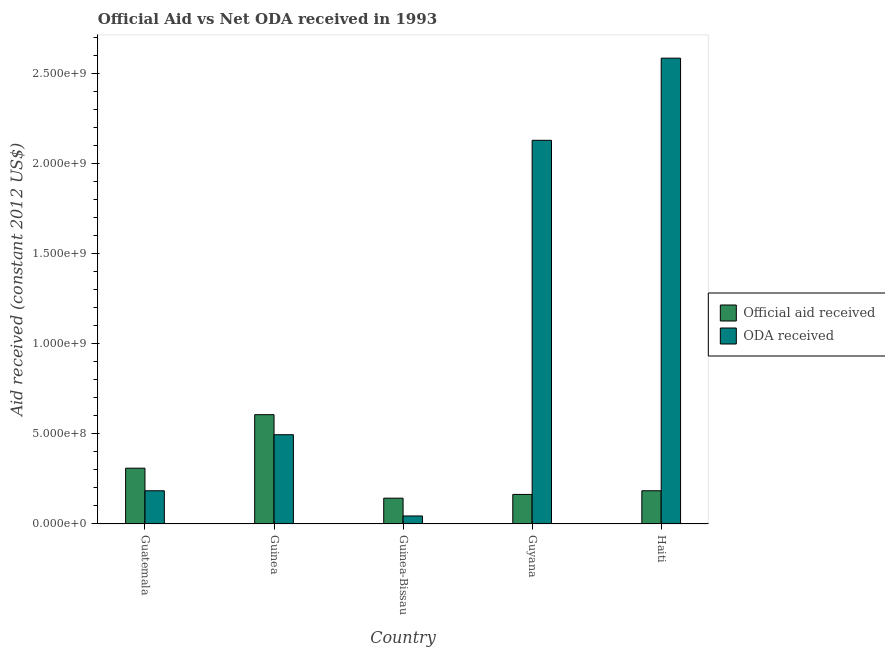How many different coloured bars are there?
Your answer should be very brief. 2. How many groups of bars are there?
Make the answer very short. 5. Are the number of bars per tick equal to the number of legend labels?
Make the answer very short. Yes. What is the label of the 1st group of bars from the left?
Offer a very short reply. Guatemala. In how many cases, is the number of bars for a given country not equal to the number of legend labels?
Give a very brief answer. 0. What is the official aid received in Haiti?
Make the answer very short. 1.84e+08. Across all countries, what is the maximum oda received?
Give a very brief answer. 2.59e+09. Across all countries, what is the minimum oda received?
Make the answer very short. 4.45e+07. In which country was the official aid received maximum?
Keep it short and to the point. Guinea. In which country was the oda received minimum?
Keep it short and to the point. Guinea-Bissau. What is the total official aid received in the graph?
Your response must be concise. 1.41e+09. What is the difference between the oda received in Guatemala and that in Guyana?
Offer a very short reply. -1.95e+09. What is the difference between the official aid received in Guyana and the oda received in Guinea?
Keep it short and to the point. -3.32e+08. What is the average official aid received per country?
Provide a short and direct response. 2.82e+08. What is the difference between the oda received and official aid received in Guatemala?
Provide a short and direct response. -1.25e+08. What is the ratio of the oda received in Guatemala to that in Guyana?
Make the answer very short. 0.09. Is the oda received in Guyana less than that in Haiti?
Provide a short and direct response. Yes. Is the difference between the oda received in Guinea and Haiti greater than the difference between the official aid received in Guinea and Haiti?
Your response must be concise. No. What is the difference between the highest and the second highest oda received?
Provide a short and direct response. 4.56e+08. What is the difference between the highest and the lowest official aid received?
Your answer should be compact. 4.64e+08. Is the sum of the official aid received in Guinea and Guinea-Bissau greater than the maximum oda received across all countries?
Ensure brevity in your answer.  No. What does the 1st bar from the left in Haiti represents?
Offer a terse response. Official aid received. What does the 1st bar from the right in Guinea-Bissau represents?
Provide a succinct answer. ODA received. How many bars are there?
Make the answer very short. 10. How many countries are there in the graph?
Your response must be concise. 5. What is the difference between two consecutive major ticks on the Y-axis?
Make the answer very short. 5.00e+08. Does the graph contain grids?
Ensure brevity in your answer.  No. Where does the legend appear in the graph?
Ensure brevity in your answer.  Center right. How many legend labels are there?
Make the answer very short. 2. How are the legend labels stacked?
Your answer should be very brief. Vertical. What is the title of the graph?
Offer a terse response. Official Aid vs Net ODA received in 1993 . Does "Secondary education" appear as one of the legend labels in the graph?
Offer a terse response. No. What is the label or title of the X-axis?
Your response must be concise. Country. What is the label or title of the Y-axis?
Your answer should be very brief. Aid received (constant 2012 US$). What is the Aid received (constant 2012 US$) in Official aid received in Guatemala?
Your answer should be compact. 3.10e+08. What is the Aid received (constant 2012 US$) of ODA received in Guatemala?
Ensure brevity in your answer.  1.84e+08. What is the Aid received (constant 2012 US$) of Official aid received in Guinea?
Keep it short and to the point. 6.07e+08. What is the Aid received (constant 2012 US$) in ODA received in Guinea?
Make the answer very short. 4.96e+08. What is the Aid received (constant 2012 US$) of Official aid received in Guinea-Bissau?
Your answer should be very brief. 1.43e+08. What is the Aid received (constant 2012 US$) of ODA received in Guinea-Bissau?
Make the answer very short. 4.45e+07. What is the Aid received (constant 2012 US$) in Official aid received in Guyana?
Make the answer very short. 1.64e+08. What is the Aid received (constant 2012 US$) in ODA received in Guyana?
Your answer should be compact. 2.13e+09. What is the Aid received (constant 2012 US$) of Official aid received in Haiti?
Your answer should be compact. 1.84e+08. What is the Aid received (constant 2012 US$) of ODA received in Haiti?
Ensure brevity in your answer.  2.59e+09. Across all countries, what is the maximum Aid received (constant 2012 US$) of Official aid received?
Offer a very short reply. 6.07e+08. Across all countries, what is the maximum Aid received (constant 2012 US$) of ODA received?
Provide a succinct answer. 2.59e+09. Across all countries, what is the minimum Aid received (constant 2012 US$) in Official aid received?
Provide a succinct answer. 1.43e+08. Across all countries, what is the minimum Aid received (constant 2012 US$) of ODA received?
Make the answer very short. 4.45e+07. What is the total Aid received (constant 2012 US$) in Official aid received in the graph?
Your answer should be very brief. 1.41e+09. What is the total Aid received (constant 2012 US$) in ODA received in the graph?
Keep it short and to the point. 5.44e+09. What is the difference between the Aid received (constant 2012 US$) of Official aid received in Guatemala and that in Guinea?
Make the answer very short. -2.97e+08. What is the difference between the Aid received (constant 2012 US$) in ODA received in Guatemala and that in Guinea?
Make the answer very short. -3.11e+08. What is the difference between the Aid received (constant 2012 US$) in Official aid received in Guatemala and that in Guinea-Bissau?
Give a very brief answer. 1.67e+08. What is the difference between the Aid received (constant 2012 US$) in ODA received in Guatemala and that in Guinea-Bissau?
Your response must be concise. 1.40e+08. What is the difference between the Aid received (constant 2012 US$) of Official aid received in Guatemala and that in Guyana?
Ensure brevity in your answer.  1.46e+08. What is the difference between the Aid received (constant 2012 US$) in ODA received in Guatemala and that in Guyana?
Your answer should be compact. -1.95e+09. What is the difference between the Aid received (constant 2012 US$) in Official aid received in Guatemala and that in Haiti?
Your response must be concise. 1.25e+08. What is the difference between the Aid received (constant 2012 US$) in ODA received in Guatemala and that in Haiti?
Your response must be concise. -2.40e+09. What is the difference between the Aid received (constant 2012 US$) in Official aid received in Guinea and that in Guinea-Bissau?
Offer a very short reply. 4.64e+08. What is the difference between the Aid received (constant 2012 US$) of ODA received in Guinea and that in Guinea-Bissau?
Your answer should be compact. 4.51e+08. What is the difference between the Aid received (constant 2012 US$) of Official aid received in Guinea and that in Guyana?
Ensure brevity in your answer.  4.43e+08. What is the difference between the Aid received (constant 2012 US$) of ODA received in Guinea and that in Guyana?
Ensure brevity in your answer.  -1.63e+09. What is the difference between the Aid received (constant 2012 US$) in Official aid received in Guinea and that in Haiti?
Make the answer very short. 4.22e+08. What is the difference between the Aid received (constant 2012 US$) of ODA received in Guinea and that in Haiti?
Ensure brevity in your answer.  -2.09e+09. What is the difference between the Aid received (constant 2012 US$) of Official aid received in Guinea-Bissau and that in Guyana?
Offer a very short reply. -2.08e+07. What is the difference between the Aid received (constant 2012 US$) of ODA received in Guinea-Bissau and that in Guyana?
Give a very brief answer. -2.09e+09. What is the difference between the Aid received (constant 2012 US$) in Official aid received in Guinea-Bissau and that in Haiti?
Your answer should be compact. -4.11e+07. What is the difference between the Aid received (constant 2012 US$) of ODA received in Guinea-Bissau and that in Haiti?
Keep it short and to the point. -2.54e+09. What is the difference between the Aid received (constant 2012 US$) in Official aid received in Guyana and that in Haiti?
Your answer should be compact. -2.04e+07. What is the difference between the Aid received (constant 2012 US$) of ODA received in Guyana and that in Haiti?
Your answer should be compact. -4.56e+08. What is the difference between the Aid received (constant 2012 US$) of Official aid received in Guatemala and the Aid received (constant 2012 US$) of ODA received in Guinea?
Your answer should be compact. -1.86e+08. What is the difference between the Aid received (constant 2012 US$) of Official aid received in Guatemala and the Aid received (constant 2012 US$) of ODA received in Guinea-Bissau?
Your answer should be compact. 2.65e+08. What is the difference between the Aid received (constant 2012 US$) of Official aid received in Guatemala and the Aid received (constant 2012 US$) of ODA received in Guyana?
Your answer should be compact. -1.82e+09. What is the difference between the Aid received (constant 2012 US$) of Official aid received in Guatemala and the Aid received (constant 2012 US$) of ODA received in Haiti?
Ensure brevity in your answer.  -2.28e+09. What is the difference between the Aid received (constant 2012 US$) of Official aid received in Guinea and the Aid received (constant 2012 US$) of ODA received in Guinea-Bissau?
Offer a terse response. 5.62e+08. What is the difference between the Aid received (constant 2012 US$) in Official aid received in Guinea and the Aid received (constant 2012 US$) in ODA received in Guyana?
Provide a succinct answer. -1.52e+09. What is the difference between the Aid received (constant 2012 US$) in Official aid received in Guinea and the Aid received (constant 2012 US$) in ODA received in Haiti?
Make the answer very short. -1.98e+09. What is the difference between the Aid received (constant 2012 US$) of Official aid received in Guinea-Bissau and the Aid received (constant 2012 US$) of ODA received in Guyana?
Provide a succinct answer. -1.99e+09. What is the difference between the Aid received (constant 2012 US$) in Official aid received in Guinea-Bissau and the Aid received (constant 2012 US$) in ODA received in Haiti?
Your answer should be very brief. -2.44e+09. What is the difference between the Aid received (constant 2012 US$) of Official aid received in Guyana and the Aid received (constant 2012 US$) of ODA received in Haiti?
Ensure brevity in your answer.  -2.42e+09. What is the average Aid received (constant 2012 US$) of Official aid received per country?
Offer a very short reply. 2.82e+08. What is the average Aid received (constant 2012 US$) in ODA received per country?
Provide a succinct answer. 1.09e+09. What is the difference between the Aid received (constant 2012 US$) of Official aid received and Aid received (constant 2012 US$) of ODA received in Guatemala?
Make the answer very short. 1.25e+08. What is the difference between the Aid received (constant 2012 US$) of Official aid received and Aid received (constant 2012 US$) of ODA received in Guinea?
Offer a terse response. 1.11e+08. What is the difference between the Aid received (constant 2012 US$) of Official aid received and Aid received (constant 2012 US$) of ODA received in Guinea-Bissau?
Provide a short and direct response. 9.88e+07. What is the difference between the Aid received (constant 2012 US$) of Official aid received and Aid received (constant 2012 US$) of ODA received in Guyana?
Your response must be concise. -1.97e+09. What is the difference between the Aid received (constant 2012 US$) of Official aid received and Aid received (constant 2012 US$) of ODA received in Haiti?
Make the answer very short. -2.40e+09. What is the ratio of the Aid received (constant 2012 US$) in Official aid received in Guatemala to that in Guinea?
Make the answer very short. 0.51. What is the ratio of the Aid received (constant 2012 US$) of ODA received in Guatemala to that in Guinea?
Provide a short and direct response. 0.37. What is the ratio of the Aid received (constant 2012 US$) of Official aid received in Guatemala to that in Guinea-Bissau?
Your answer should be very brief. 2.16. What is the ratio of the Aid received (constant 2012 US$) in ODA received in Guatemala to that in Guinea-Bissau?
Make the answer very short. 4.15. What is the ratio of the Aid received (constant 2012 US$) in Official aid received in Guatemala to that in Guyana?
Provide a short and direct response. 1.89. What is the ratio of the Aid received (constant 2012 US$) in ODA received in Guatemala to that in Guyana?
Your response must be concise. 0.09. What is the ratio of the Aid received (constant 2012 US$) in Official aid received in Guatemala to that in Haiti?
Offer a terse response. 1.68. What is the ratio of the Aid received (constant 2012 US$) of ODA received in Guatemala to that in Haiti?
Give a very brief answer. 0.07. What is the ratio of the Aid received (constant 2012 US$) in Official aid received in Guinea to that in Guinea-Bissau?
Provide a short and direct response. 4.24. What is the ratio of the Aid received (constant 2012 US$) in ODA received in Guinea to that in Guinea-Bissau?
Make the answer very short. 11.14. What is the ratio of the Aid received (constant 2012 US$) in Official aid received in Guinea to that in Guyana?
Offer a very short reply. 3.7. What is the ratio of the Aid received (constant 2012 US$) in ODA received in Guinea to that in Guyana?
Make the answer very short. 0.23. What is the ratio of the Aid received (constant 2012 US$) in Official aid received in Guinea to that in Haiti?
Your answer should be compact. 3.29. What is the ratio of the Aid received (constant 2012 US$) of ODA received in Guinea to that in Haiti?
Give a very brief answer. 0.19. What is the ratio of the Aid received (constant 2012 US$) of Official aid received in Guinea-Bissau to that in Guyana?
Provide a short and direct response. 0.87. What is the ratio of the Aid received (constant 2012 US$) of ODA received in Guinea-Bissau to that in Guyana?
Ensure brevity in your answer.  0.02. What is the ratio of the Aid received (constant 2012 US$) in Official aid received in Guinea-Bissau to that in Haiti?
Keep it short and to the point. 0.78. What is the ratio of the Aid received (constant 2012 US$) of ODA received in Guinea-Bissau to that in Haiti?
Provide a succinct answer. 0.02. What is the ratio of the Aid received (constant 2012 US$) in Official aid received in Guyana to that in Haiti?
Provide a succinct answer. 0.89. What is the ratio of the Aid received (constant 2012 US$) of ODA received in Guyana to that in Haiti?
Your response must be concise. 0.82. What is the difference between the highest and the second highest Aid received (constant 2012 US$) in Official aid received?
Your response must be concise. 2.97e+08. What is the difference between the highest and the second highest Aid received (constant 2012 US$) in ODA received?
Your answer should be very brief. 4.56e+08. What is the difference between the highest and the lowest Aid received (constant 2012 US$) of Official aid received?
Provide a short and direct response. 4.64e+08. What is the difference between the highest and the lowest Aid received (constant 2012 US$) of ODA received?
Your response must be concise. 2.54e+09. 